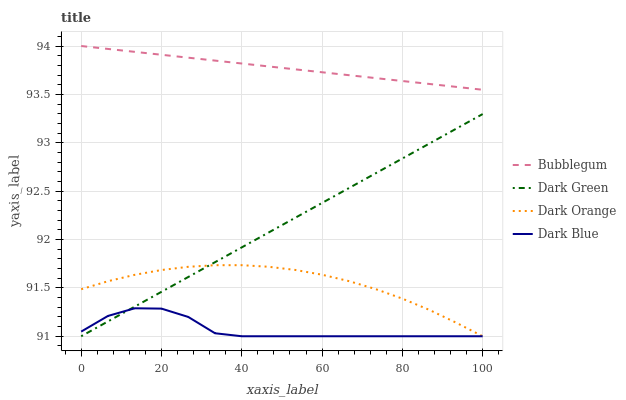Does Dark Blue have the minimum area under the curve?
Answer yes or no. Yes. Does Bubblegum have the maximum area under the curve?
Answer yes or no. Yes. Does Bubblegum have the minimum area under the curve?
Answer yes or no. No. Does Dark Blue have the maximum area under the curve?
Answer yes or no. No. Is Dark Green the smoothest?
Answer yes or no. Yes. Is Dark Blue the roughest?
Answer yes or no. Yes. Is Bubblegum the smoothest?
Answer yes or no. No. Is Bubblegum the roughest?
Answer yes or no. No. Does Bubblegum have the lowest value?
Answer yes or no. No. Does Bubblegum have the highest value?
Answer yes or no. Yes. Does Dark Blue have the highest value?
Answer yes or no. No. Is Dark Green less than Bubblegum?
Answer yes or no. Yes. Is Bubblegum greater than Dark Orange?
Answer yes or no. Yes. Does Dark Orange intersect Dark Blue?
Answer yes or no. Yes. Is Dark Orange less than Dark Blue?
Answer yes or no. No. Is Dark Orange greater than Dark Blue?
Answer yes or no. No. Does Dark Green intersect Bubblegum?
Answer yes or no. No. 